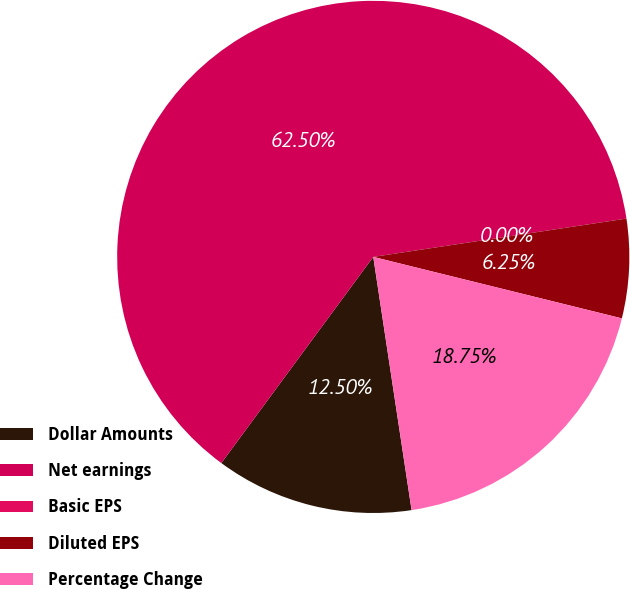Convert chart to OTSL. <chart><loc_0><loc_0><loc_500><loc_500><pie_chart><fcel>Dollar Amounts<fcel>Net earnings<fcel>Basic EPS<fcel>Diluted EPS<fcel>Percentage Change<nl><fcel>12.5%<fcel>62.5%<fcel>0.0%<fcel>6.25%<fcel>18.75%<nl></chart> 